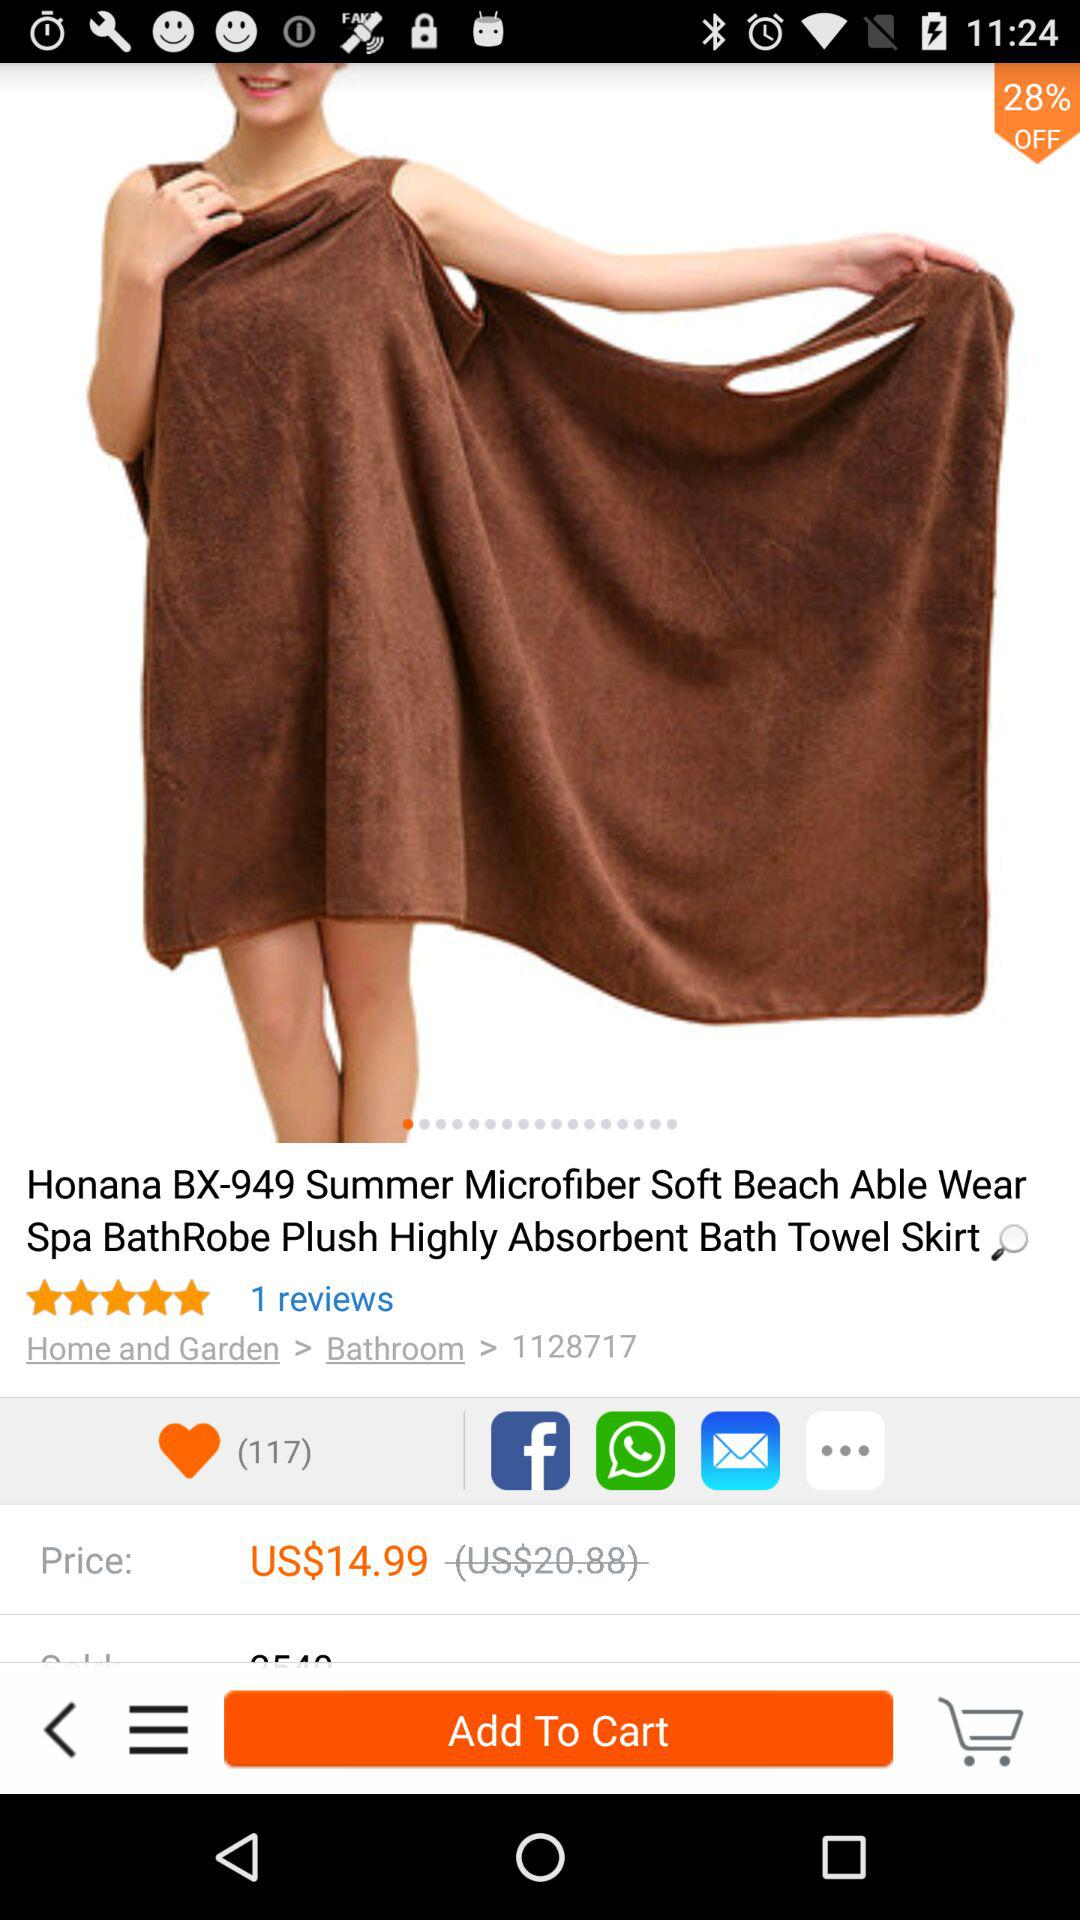How much is the rating? The rating is 5 stars. 